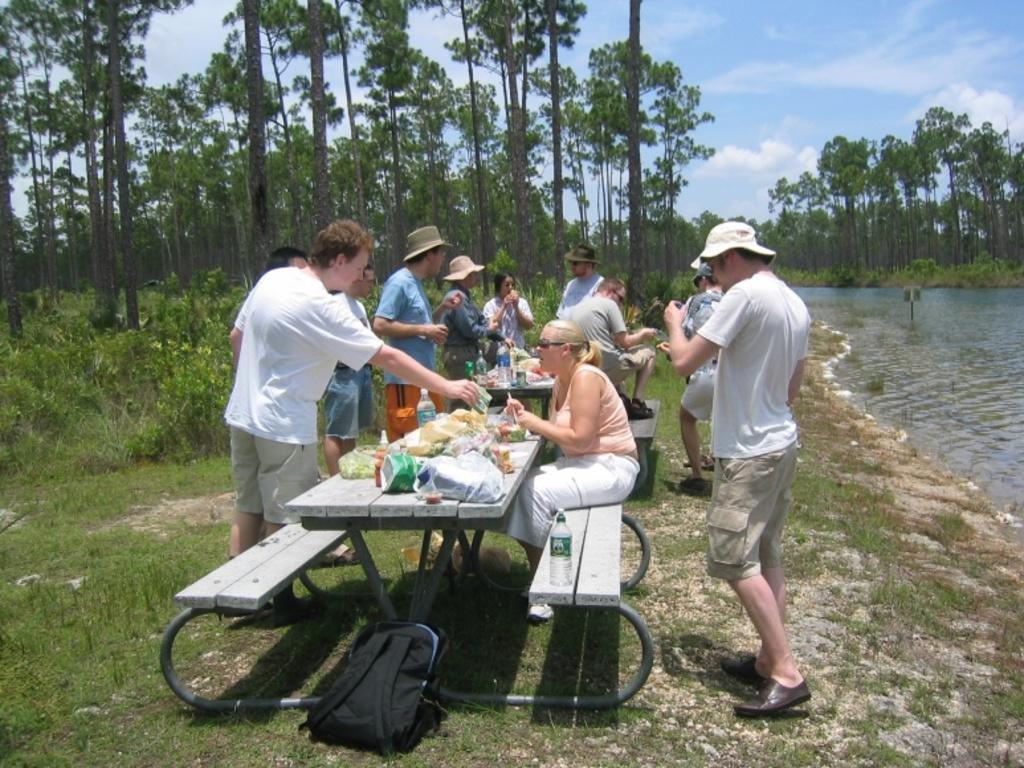Describe this image in one or two sentences. In the background we can see the clouds in the sky, trees. In this picture we can see the pants, people. We can see the benches and tables. We can see a woman is sitting on a bench. On the tables we can see the water bottles, food items and few objects. We can see the people are standing and few wore hats. At the bottom portion of the picture we can see a backpack on the green grass. On the right side of the picture we can see the water and it seems like a board. 